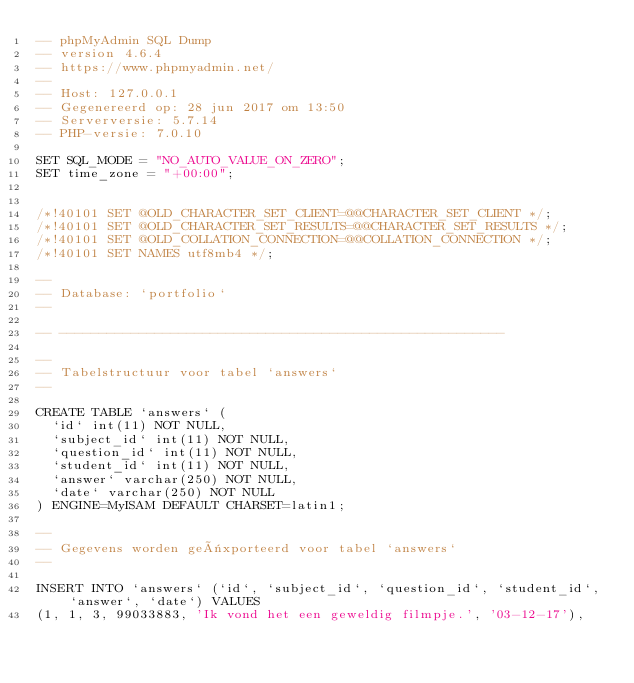<code> <loc_0><loc_0><loc_500><loc_500><_SQL_>-- phpMyAdmin SQL Dump
-- version 4.6.4
-- https://www.phpmyadmin.net/
--
-- Host: 127.0.0.1
-- Gegenereerd op: 28 jun 2017 om 13:50
-- Serverversie: 5.7.14
-- PHP-versie: 7.0.10

SET SQL_MODE = "NO_AUTO_VALUE_ON_ZERO";
SET time_zone = "+00:00";


/*!40101 SET @OLD_CHARACTER_SET_CLIENT=@@CHARACTER_SET_CLIENT */;
/*!40101 SET @OLD_CHARACTER_SET_RESULTS=@@CHARACTER_SET_RESULTS */;
/*!40101 SET @OLD_COLLATION_CONNECTION=@@COLLATION_CONNECTION */;
/*!40101 SET NAMES utf8mb4 */;

--
-- Database: `portfolio`
--

-- --------------------------------------------------------

--
-- Tabelstructuur voor tabel `answers`
--

CREATE TABLE `answers` (
  `id` int(11) NOT NULL,
  `subject_id` int(11) NOT NULL,
  `question_id` int(11) NOT NULL,
  `student_id` int(11) NOT NULL,
  `answer` varchar(250) NOT NULL,
  `date` varchar(250) NOT NULL
) ENGINE=MyISAM DEFAULT CHARSET=latin1;

--
-- Gegevens worden geëxporteerd voor tabel `answers`
--

INSERT INTO `answers` (`id`, `subject_id`, `question_id`, `student_id`, `answer`, `date`) VALUES
(1, 1, 3, 99033883, 'Ik vond het een geweldig filmpje.', '03-12-17'),</code> 